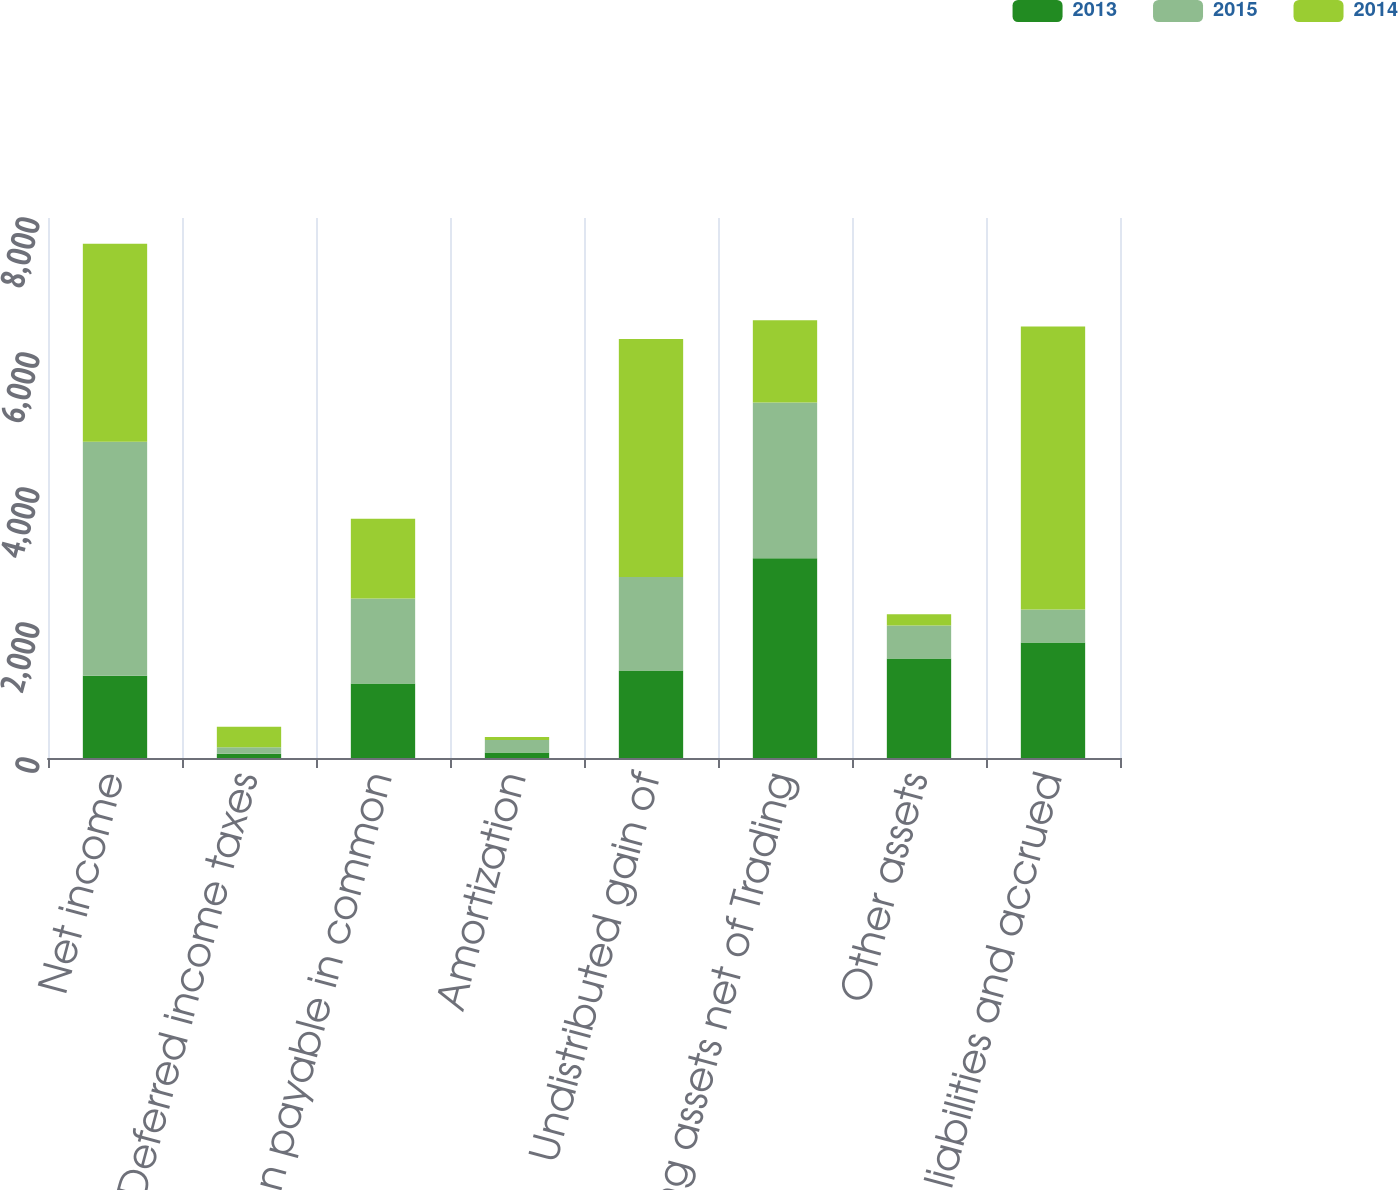Convert chart. <chart><loc_0><loc_0><loc_500><loc_500><stacked_bar_chart><ecel><fcel>Net income<fcel>Deferred income taxes<fcel>Compensation payable in common<fcel>Amortization<fcel>Undistributed gain of<fcel>Trading assets net of Trading<fcel>Other assets<fcel>Other liabilities and accrued<nl><fcel>2013<fcel>1220<fcel>63<fcel>1104<fcel>83<fcel>1298<fcel>2958<fcel>1474<fcel>1711<nl><fcel>2015<fcel>3467<fcel>98<fcel>1260<fcel>182<fcel>1383<fcel>2307<fcel>490<fcel>488<nl><fcel>2014<fcel>2932<fcel>303<fcel>1180<fcel>47<fcel>3528<fcel>1220<fcel>165<fcel>4192<nl></chart> 